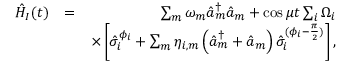Convert formula to latex. <formula><loc_0><loc_0><loc_500><loc_500>\begin{array} { r l r } { \hat { H } _ { I } ( t ) } & { = } & { \sum _ { m } \omega _ { m } \hat { a } _ { m } ^ { \dag } \hat { a } _ { m } + \cos \mu t \sum _ { i } \Omega _ { i } } \\ & { \times \left [ \hat { \sigma } _ { i } ^ { \phi _ { i } } + \sum _ { m } \eta _ { i , m } \left ( \hat { a } _ { m } ^ { \dag } + \hat { a } _ { m } \right ) \hat { \sigma } _ { i } ^ { ( \phi _ { i } - \frac { \pi } { 2 } ) } \right ] , } \end{array}</formula> 